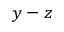<formula> <loc_0><loc_0><loc_500><loc_500>y - z</formula> 